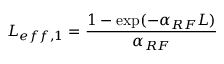Convert formula to latex. <formula><loc_0><loc_0><loc_500><loc_500>L _ { e f f , 1 } = \frac { 1 - \exp ( - \alpha _ { R F } L ) } { \alpha _ { R F } }</formula> 